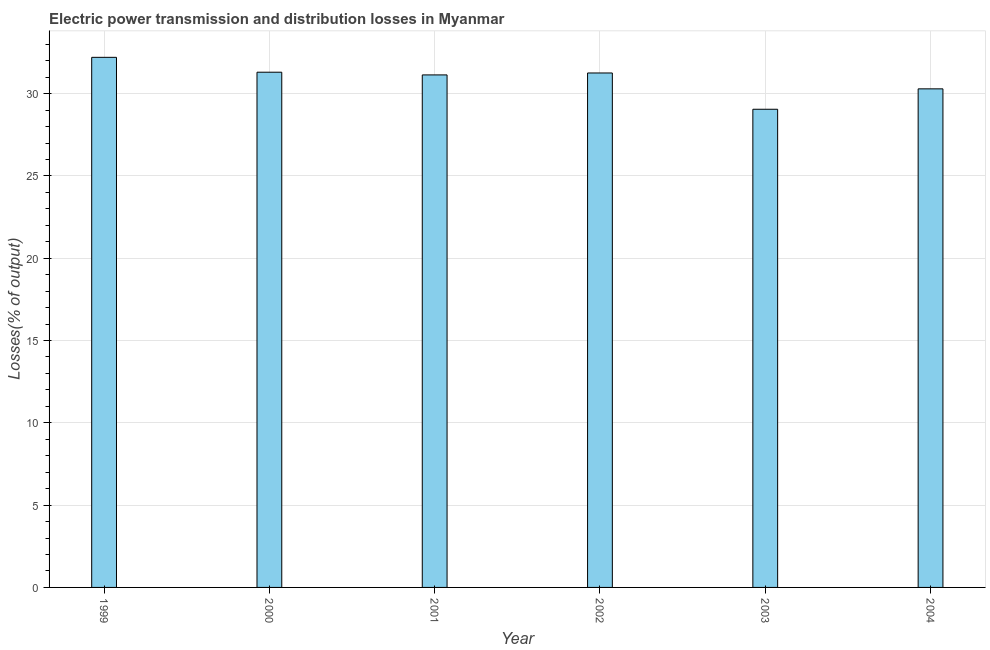Does the graph contain grids?
Your response must be concise. Yes. What is the title of the graph?
Offer a terse response. Electric power transmission and distribution losses in Myanmar. What is the label or title of the Y-axis?
Your answer should be compact. Losses(% of output). What is the electric power transmission and distribution losses in 2001?
Provide a succinct answer. 31.14. Across all years, what is the maximum electric power transmission and distribution losses?
Ensure brevity in your answer.  32.21. Across all years, what is the minimum electric power transmission and distribution losses?
Make the answer very short. 29.05. In which year was the electric power transmission and distribution losses maximum?
Your answer should be compact. 1999. In which year was the electric power transmission and distribution losses minimum?
Give a very brief answer. 2003. What is the sum of the electric power transmission and distribution losses?
Offer a very short reply. 185.24. What is the difference between the electric power transmission and distribution losses in 2001 and 2002?
Offer a terse response. -0.12. What is the average electric power transmission and distribution losses per year?
Make the answer very short. 30.87. What is the median electric power transmission and distribution losses?
Your response must be concise. 31.2. Do a majority of the years between 1999 and 2003 (inclusive) have electric power transmission and distribution losses greater than 28 %?
Your answer should be very brief. Yes. Is the electric power transmission and distribution losses in 2001 less than that in 2003?
Your answer should be very brief. No. What is the difference between the highest and the second highest electric power transmission and distribution losses?
Provide a succinct answer. 0.9. What is the difference between the highest and the lowest electric power transmission and distribution losses?
Make the answer very short. 3.15. What is the difference between two consecutive major ticks on the Y-axis?
Your answer should be compact. 5. What is the Losses(% of output) in 1999?
Offer a very short reply. 32.21. What is the Losses(% of output) in 2000?
Make the answer very short. 31.3. What is the Losses(% of output) of 2001?
Offer a very short reply. 31.14. What is the Losses(% of output) of 2002?
Provide a short and direct response. 31.25. What is the Losses(% of output) in 2003?
Provide a short and direct response. 29.05. What is the Losses(% of output) of 2004?
Your response must be concise. 30.29. What is the difference between the Losses(% of output) in 1999 and 2000?
Your answer should be very brief. 0.9. What is the difference between the Losses(% of output) in 1999 and 2001?
Give a very brief answer. 1.07. What is the difference between the Losses(% of output) in 1999 and 2002?
Make the answer very short. 0.95. What is the difference between the Losses(% of output) in 1999 and 2003?
Your response must be concise. 3.15. What is the difference between the Losses(% of output) in 1999 and 2004?
Your answer should be very brief. 1.91. What is the difference between the Losses(% of output) in 2000 and 2001?
Your answer should be compact. 0.16. What is the difference between the Losses(% of output) in 2000 and 2002?
Ensure brevity in your answer.  0.05. What is the difference between the Losses(% of output) in 2000 and 2003?
Your answer should be compact. 2.25. What is the difference between the Losses(% of output) in 2000 and 2004?
Provide a short and direct response. 1.01. What is the difference between the Losses(% of output) in 2001 and 2002?
Your answer should be very brief. -0.12. What is the difference between the Losses(% of output) in 2001 and 2003?
Your answer should be very brief. 2.09. What is the difference between the Losses(% of output) in 2001 and 2004?
Your response must be concise. 0.85. What is the difference between the Losses(% of output) in 2002 and 2003?
Provide a short and direct response. 2.2. What is the difference between the Losses(% of output) in 2002 and 2004?
Ensure brevity in your answer.  0.96. What is the difference between the Losses(% of output) in 2003 and 2004?
Provide a succinct answer. -1.24. What is the ratio of the Losses(% of output) in 1999 to that in 2001?
Give a very brief answer. 1.03. What is the ratio of the Losses(% of output) in 1999 to that in 2002?
Offer a terse response. 1.03. What is the ratio of the Losses(% of output) in 1999 to that in 2003?
Provide a short and direct response. 1.11. What is the ratio of the Losses(% of output) in 1999 to that in 2004?
Ensure brevity in your answer.  1.06. What is the ratio of the Losses(% of output) in 2000 to that in 2001?
Give a very brief answer. 1. What is the ratio of the Losses(% of output) in 2000 to that in 2002?
Ensure brevity in your answer.  1. What is the ratio of the Losses(% of output) in 2000 to that in 2003?
Ensure brevity in your answer.  1.08. What is the ratio of the Losses(% of output) in 2000 to that in 2004?
Offer a terse response. 1.03. What is the ratio of the Losses(% of output) in 2001 to that in 2003?
Give a very brief answer. 1.07. What is the ratio of the Losses(% of output) in 2001 to that in 2004?
Ensure brevity in your answer.  1.03. What is the ratio of the Losses(% of output) in 2002 to that in 2003?
Give a very brief answer. 1.08. What is the ratio of the Losses(% of output) in 2002 to that in 2004?
Give a very brief answer. 1.03. 